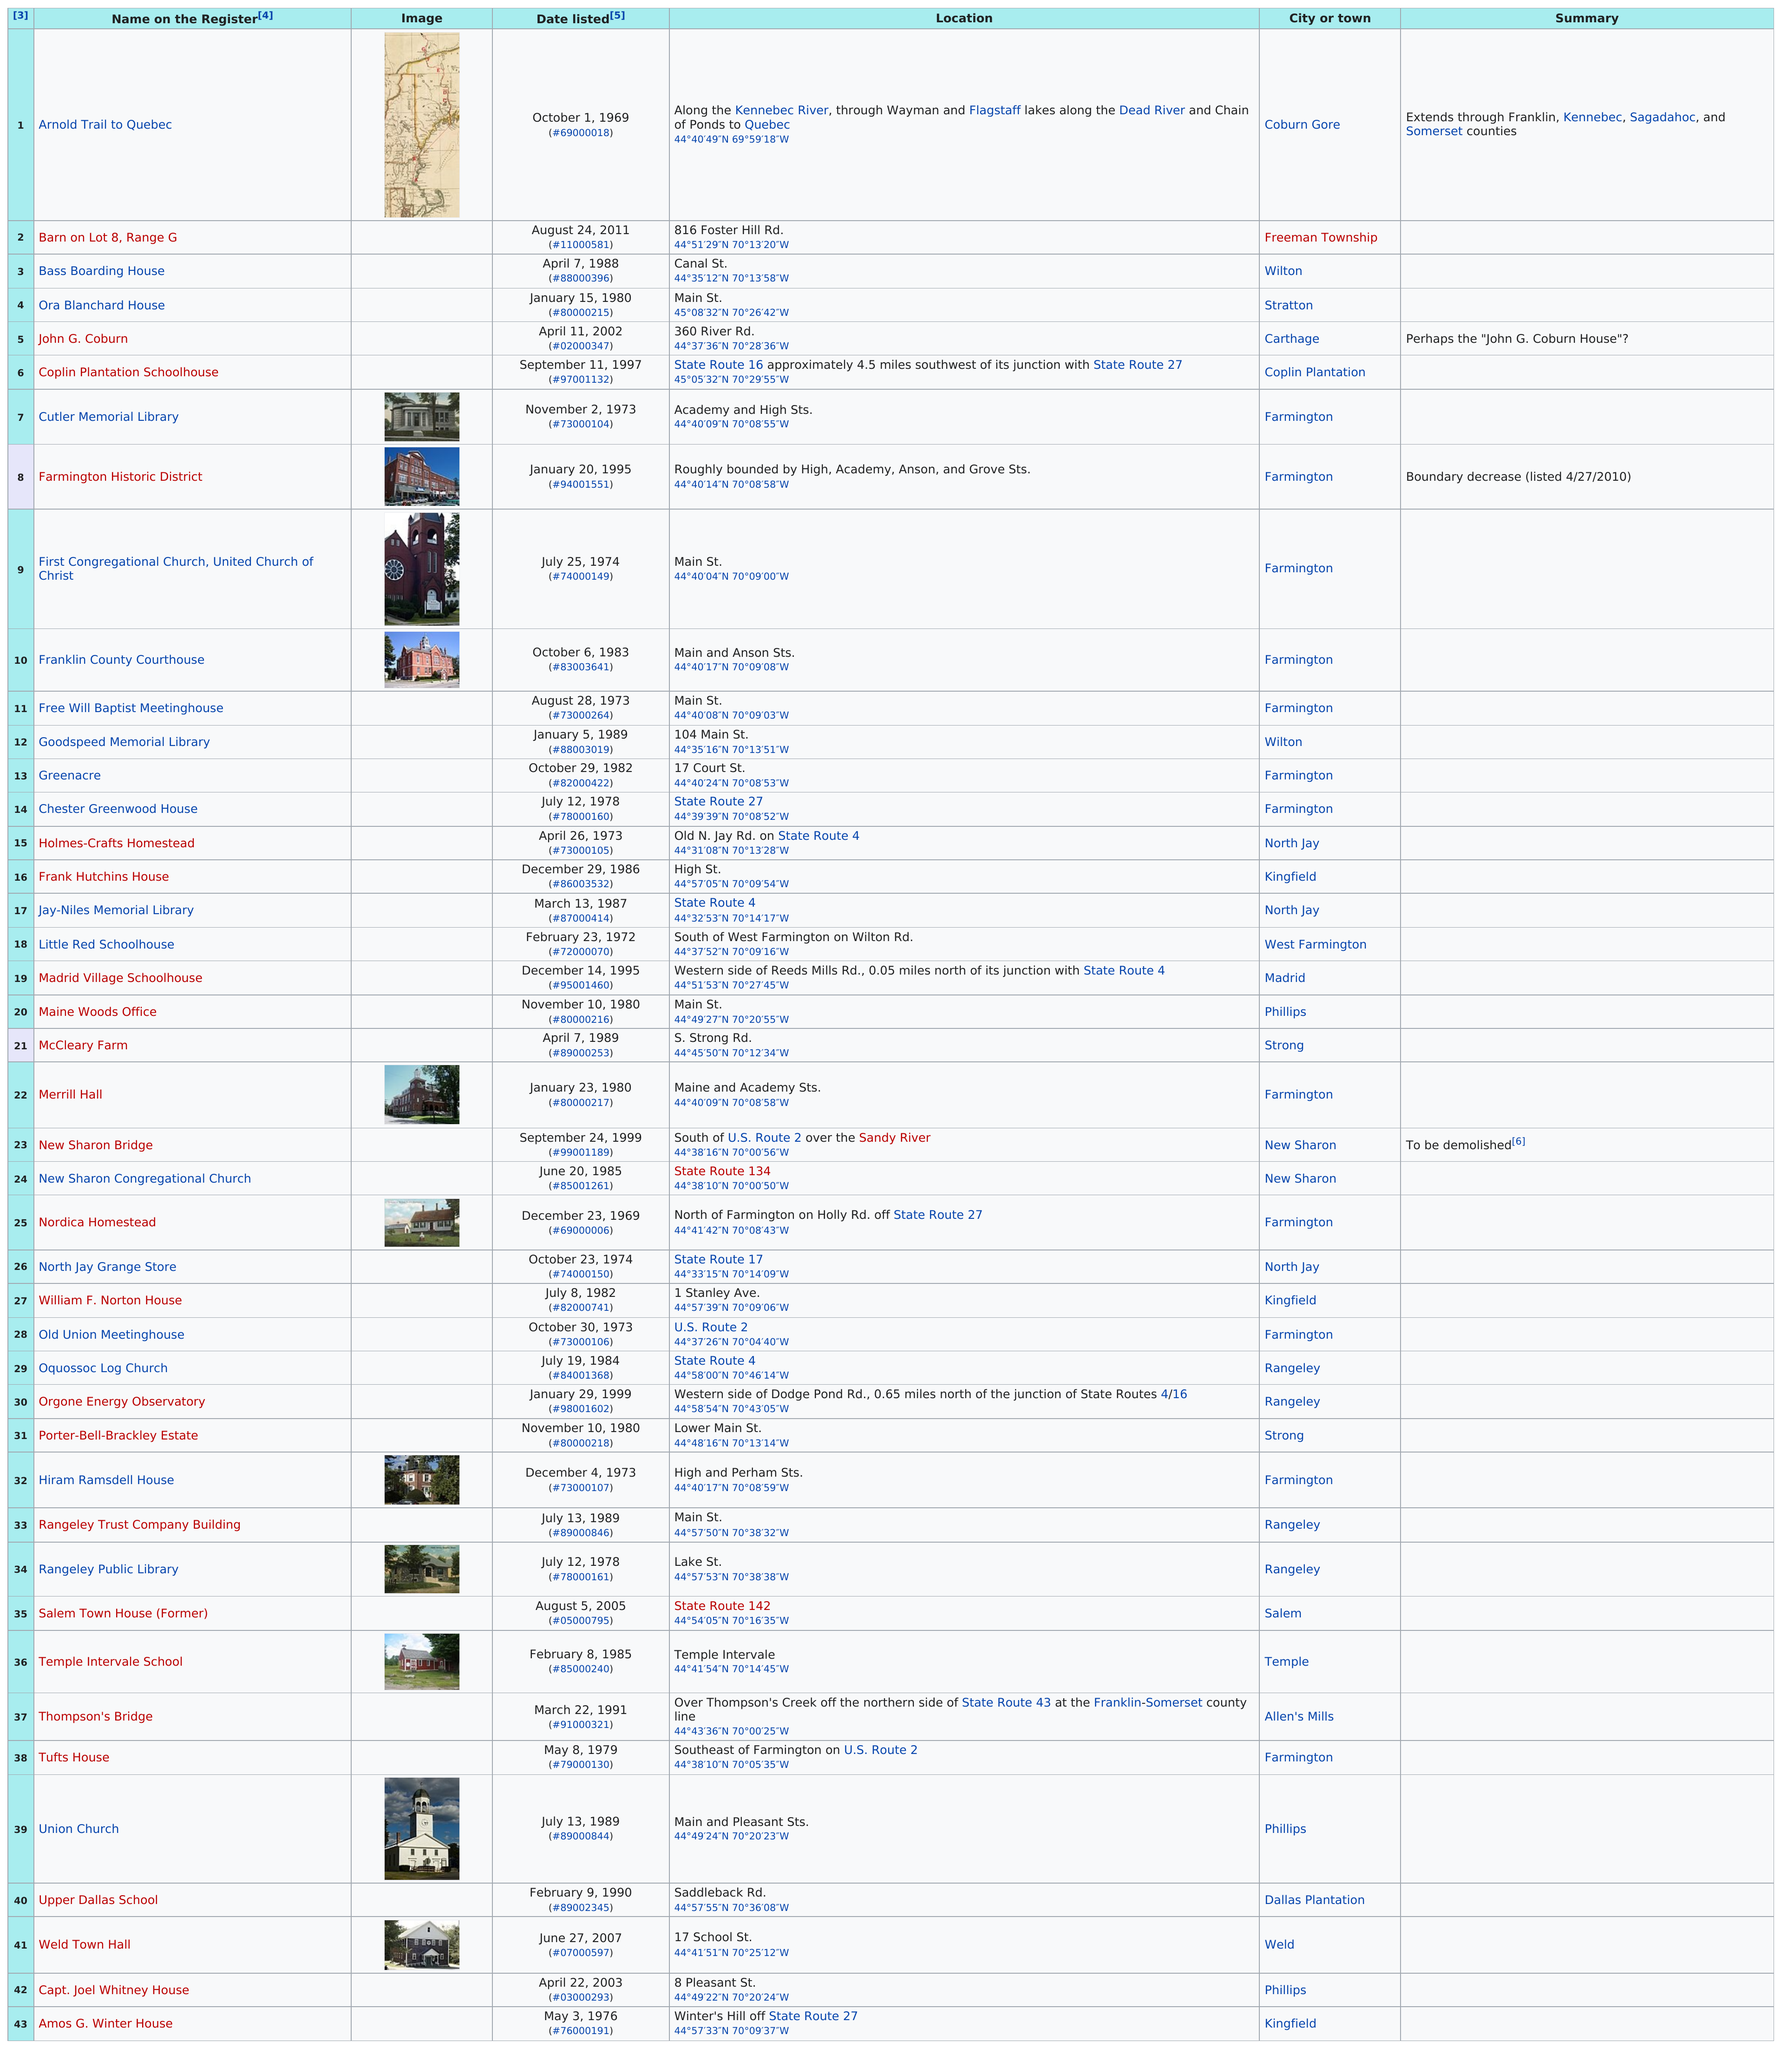Draw attention to some important aspects in this diagram. There is an 8-year difference between the listings for the bass boarding house and the ora blanchard house. Between 1970 and 1974, a total of 19 sites were added to the World Heritage List. The Nordica Homestead was added to the list before the Mccleary farm. There exists only one historic place in Coburn Gore, and it is the Arnold Trail that leads to Quebec. There are a total of 12 listings in Farmington. 